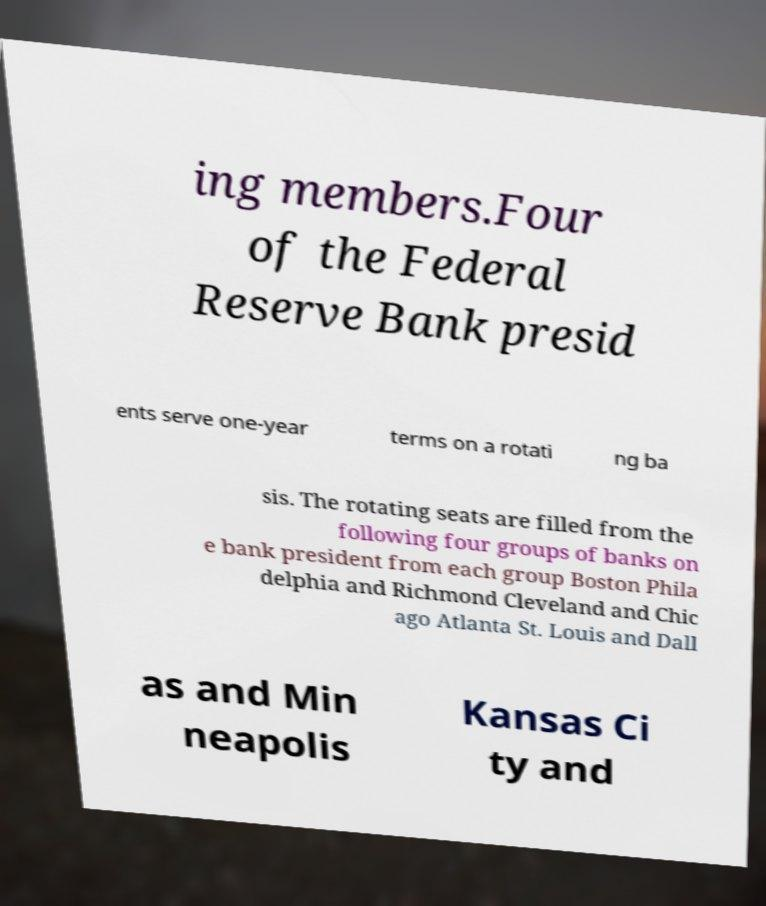There's text embedded in this image that I need extracted. Can you transcribe it verbatim? ing members.Four of the Federal Reserve Bank presid ents serve one-year terms on a rotati ng ba sis. The rotating seats are filled from the following four groups of banks on e bank president from each group Boston Phila delphia and Richmond Cleveland and Chic ago Atlanta St. Louis and Dall as and Min neapolis Kansas Ci ty and 